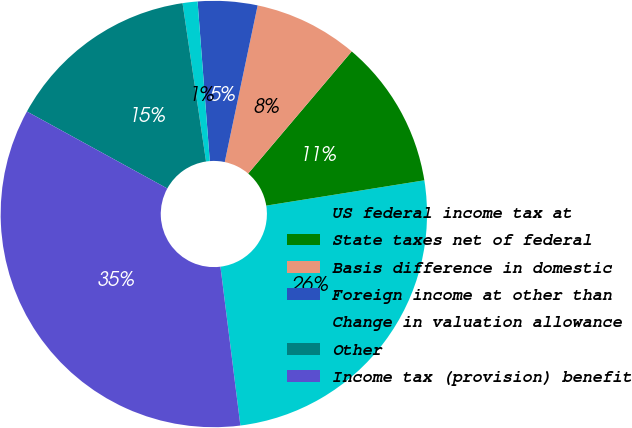Convert chart to OTSL. <chart><loc_0><loc_0><loc_500><loc_500><pie_chart><fcel>US federal income tax at<fcel>State taxes net of federal<fcel>Basis difference in domestic<fcel>Foreign income at other than<fcel>Change in valuation allowance<fcel>Other<fcel>Income tax (provision) benefit<nl><fcel>25.54%<fcel>11.28%<fcel>7.9%<fcel>4.51%<fcel>1.13%<fcel>14.67%<fcel>34.97%<nl></chart> 